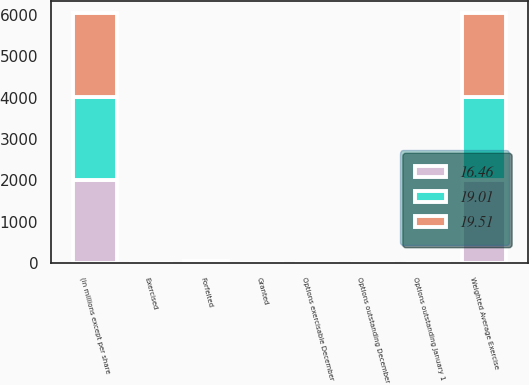Convert chart. <chart><loc_0><loc_0><loc_500><loc_500><stacked_bar_chart><ecel><fcel>(in millions except per share<fcel>Options outstanding January 1<fcel>Granted<fcel>Exercised<fcel>Options outstanding December<fcel>Options exercisable December<fcel>Weighted Average Exercise<fcel>Forfeited<nl><fcel>16.46<fcel>2013<fcel>5.6<fcel>0.9<fcel>1.6<fcel>4.8<fcel>2.3<fcel>2013<fcel>23.1<nl><fcel>19.51<fcel>2012<fcel>5.8<fcel>1.2<fcel>1.4<fcel>5.6<fcel>3<fcel>2012<fcel>20.66<nl><fcel>19.01<fcel>2011<fcel>5.7<fcel>1<fcel>0.8<fcel>5.8<fcel>3.5<fcel>2011<fcel>19.84<nl></chart> 